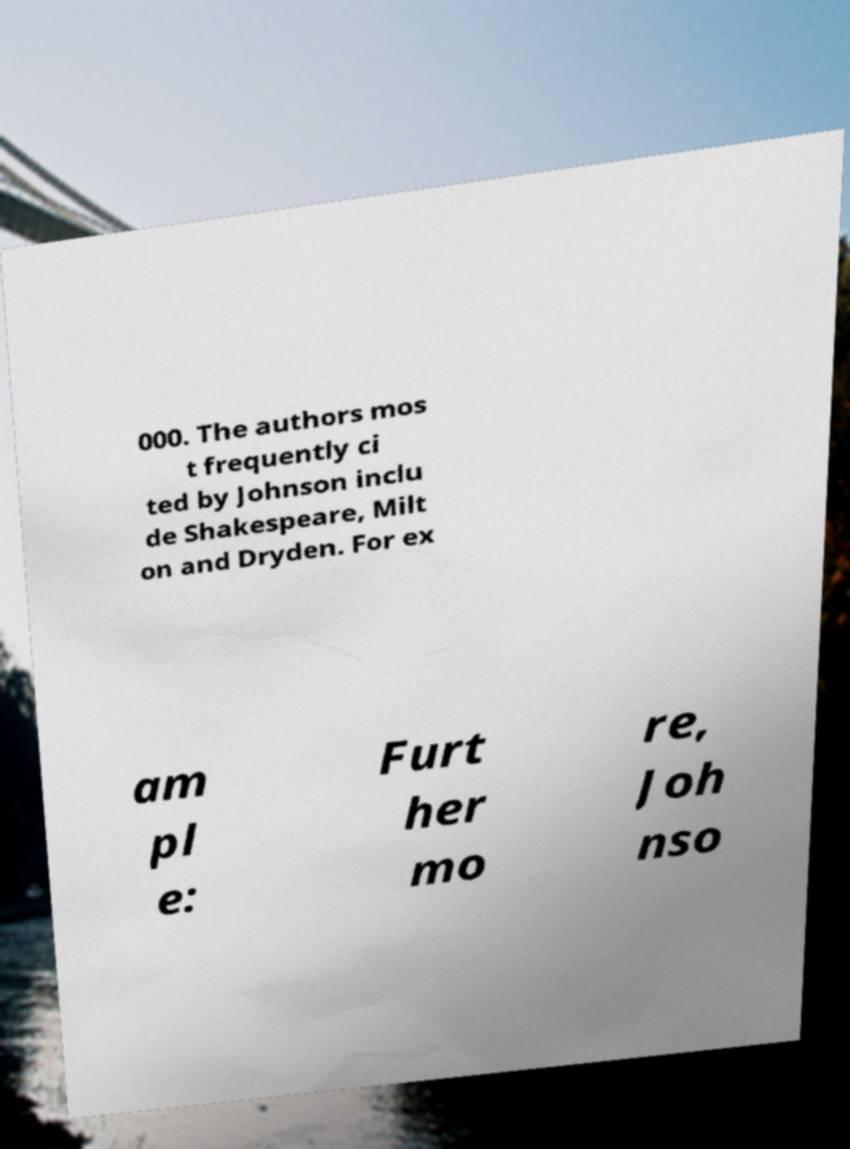Can you read and provide the text displayed in the image?This photo seems to have some interesting text. Can you extract and type it out for me? 000. The authors mos t frequently ci ted by Johnson inclu de Shakespeare, Milt on and Dryden. For ex am pl e: Furt her mo re, Joh nso 